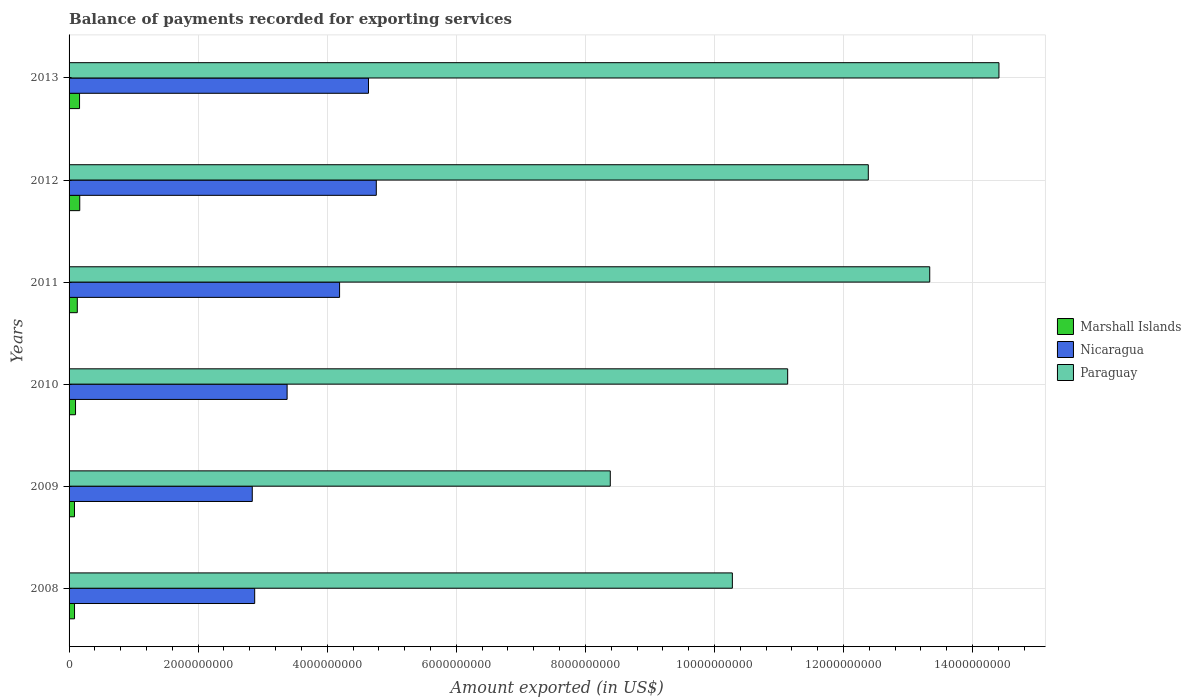How many different coloured bars are there?
Your response must be concise. 3. How many bars are there on the 2nd tick from the top?
Your answer should be very brief. 3. What is the amount exported in Paraguay in 2009?
Offer a very short reply. 8.39e+09. Across all years, what is the maximum amount exported in Marshall Islands?
Keep it short and to the point. 1.65e+08. Across all years, what is the minimum amount exported in Nicaragua?
Keep it short and to the point. 2.84e+09. In which year was the amount exported in Paraguay maximum?
Offer a very short reply. 2013. What is the total amount exported in Paraguay in the graph?
Provide a succinct answer. 6.99e+1. What is the difference between the amount exported in Marshall Islands in 2008 and that in 2011?
Offer a terse response. -4.29e+07. What is the difference between the amount exported in Marshall Islands in 2009 and the amount exported in Paraguay in 2011?
Make the answer very short. -1.33e+1. What is the average amount exported in Marshall Islands per year?
Your answer should be compact. 1.21e+08. In the year 2011, what is the difference between the amount exported in Nicaragua and amount exported in Paraguay?
Offer a terse response. -9.14e+09. What is the ratio of the amount exported in Marshall Islands in 2011 to that in 2013?
Keep it short and to the point. 0.79. What is the difference between the highest and the second highest amount exported in Paraguay?
Ensure brevity in your answer.  1.07e+09. What is the difference between the highest and the lowest amount exported in Nicaragua?
Provide a short and direct response. 1.92e+09. In how many years, is the amount exported in Paraguay greater than the average amount exported in Paraguay taken over all years?
Provide a succinct answer. 3. Is the sum of the amount exported in Nicaragua in 2008 and 2013 greater than the maximum amount exported in Paraguay across all years?
Ensure brevity in your answer.  No. What does the 1st bar from the top in 2009 represents?
Keep it short and to the point. Paraguay. What does the 3rd bar from the bottom in 2013 represents?
Keep it short and to the point. Paraguay. Is it the case that in every year, the sum of the amount exported in Nicaragua and amount exported in Marshall Islands is greater than the amount exported in Paraguay?
Give a very brief answer. No. How many bars are there?
Provide a short and direct response. 18. Are all the bars in the graph horizontal?
Give a very brief answer. Yes. What is the difference between two consecutive major ticks on the X-axis?
Provide a succinct answer. 2.00e+09. Does the graph contain grids?
Ensure brevity in your answer.  Yes. How many legend labels are there?
Keep it short and to the point. 3. What is the title of the graph?
Provide a short and direct response. Balance of payments recorded for exporting services. What is the label or title of the X-axis?
Give a very brief answer. Amount exported (in US$). What is the Amount exported (in US$) of Marshall Islands in 2008?
Offer a terse response. 8.45e+07. What is the Amount exported (in US$) of Nicaragua in 2008?
Your answer should be compact. 2.88e+09. What is the Amount exported (in US$) in Paraguay in 2008?
Give a very brief answer. 1.03e+1. What is the Amount exported (in US$) of Marshall Islands in 2009?
Ensure brevity in your answer.  8.38e+07. What is the Amount exported (in US$) of Nicaragua in 2009?
Your answer should be compact. 2.84e+09. What is the Amount exported (in US$) in Paraguay in 2009?
Your answer should be compact. 8.39e+09. What is the Amount exported (in US$) of Marshall Islands in 2010?
Make the answer very short. 1.00e+08. What is the Amount exported (in US$) in Nicaragua in 2010?
Ensure brevity in your answer.  3.38e+09. What is the Amount exported (in US$) in Paraguay in 2010?
Your response must be concise. 1.11e+1. What is the Amount exported (in US$) in Marshall Islands in 2011?
Give a very brief answer. 1.27e+08. What is the Amount exported (in US$) in Nicaragua in 2011?
Your answer should be very brief. 4.19e+09. What is the Amount exported (in US$) of Paraguay in 2011?
Give a very brief answer. 1.33e+1. What is the Amount exported (in US$) of Marshall Islands in 2012?
Keep it short and to the point. 1.65e+08. What is the Amount exported (in US$) in Nicaragua in 2012?
Your answer should be very brief. 4.76e+09. What is the Amount exported (in US$) of Paraguay in 2012?
Your answer should be compact. 1.24e+1. What is the Amount exported (in US$) of Marshall Islands in 2013?
Your answer should be very brief. 1.62e+08. What is the Amount exported (in US$) in Nicaragua in 2013?
Provide a short and direct response. 4.64e+09. What is the Amount exported (in US$) in Paraguay in 2013?
Offer a very short reply. 1.44e+1. Across all years, what is the maximum Amount exported (in US$) of Marshall Islands?
Provide a short and direct response. 1.65e+08. Across all years, what is the maximum Amount exported (in US$) of Nicaragua?
Offer a terse response. 4.76e+09. Across all years, what is the maximum Amount exported (in US$) in Paraguay?
Give a very brief answer. 1.44e+1. Across all years, what is the minimum Amount exported (in US$) of Marshall Islands?
Your response must be concise. 8.38e+07. Across all years, what is the minimum Amount exported (in US$) in Nicaragua?
Your answer should be compact. 2.84e+09. Across all years, what is the minimum Amount exported (in US$) of Paraguay?
Your answer should be compact. 8.39e+09. What is the total Amount exported (in US$) in Marshall Islands in the graph?
Make the answer very short. 7.24e+08. What is the total Amount exported (in US$) in Nicaragua in the graph?
Your answer should be very brief. 2.27e+1. What is the total Amount exported (in US$) of Paraguay in the graph?
Keep it short and to the point. 6.99e+1. What is the difference between the Amount exported (in US$) in Marshall Islands in 2008 and that in 2009?
Make the answer very short. 7.06e+05. What is the difference between the Amount exported (in US$) in Nicaragua in 2008 and that in 2009?
Your answer should be compact. 3.75e+07. What is the difference between the Amount exported (in US$) of Paraguay in 2008 and that in 2009?
Provide a short and direct response. 1.89e+09. What is the difference between the Amount exported (in US$) of Marshall Islands in 2008 and that in 2010?
Make the answer very short. -1.57e+07. What is the difference between the Amount exported (in US$) in Nicaragua in 2008 and that in 2010?
Provide a succinct answer. -5.02e+08. What is the difference between the Amount exported (in US$) in Paraguay in 2008 and that in 2010?
Offer a very short reply. -8.57e+08. What is the difference between the Amount exported (in US$) of Marshall Islands in 2008 and that in 2011?
Provide a succinct answer. -4.29e+07. What is the difference between the Amount exported (in US$) in Nicaragua in 2008 and that in 2011?
Provide a succinct answer. -1.32e+09. What is the difference between the Amount exported (in US$) of Paraguay in 2008 and that in 2011?
Ensure brevity in your answer.  -3.06e+09. What is the difference between the Amount exported (in US$) of Marshall Islands in 2008 and that in 2012?
Provide a short and direct response. -8.09e+07. What is the difference between the Amount exported (in US$) in Nicaragua in 2008 and that in 2012?
Offer a terse response. -1.88e+09. What is the difference between the Amount exported (in US$) of Paraguay in 2008 and that in 2012?
Make the answer very short. -2.11e+09. What is the difference between the Amount exported (in US$) of Marshall Islands in 2008 and that in 2013?
Provide a succinct answer. -7.77e+07. What is the difference between the Amount exported (in US$) in Nicaragua in 2008 and that in 2013?
Give a very brief answer. -1.76e+09. What is the difference between the Amount exported (in US$) of Paraguay in 2008 and that in 2013?
Ensure brevity in your answer.  -4.13e+09. What is the difference between the Amount exported (in US$) of Marshall Islands in 2009 and that in 2010?
Provide a short and direct response. -1.64e+07. What is the difference between the Amount exported (in US$) in Nicaragua in 2009 and that in 2010?
Provide a succinct answer. -5.40e+08. What is the difference between the Amount exported (in US$) in Paraguay in 2009 and that in 2010?
Offer a very short reply. -2.75e+09. What is the difference between the Amount exported (in US$) of Marshall Islands in 2009 and that in 2011?
Keep it short and to the point. -4.36e+07. What is the difference between the Amount exported (in US$) of Nicaragua in 2009 and that in 2011?
Provide a short and direct response. -1.35e+09. What is the difference between the Amount exported (in US$) of Paraguay in 2009 and that in 2011?
Your answer should be compact. -4.95e+09. What is the difference between the Amount exported (in US$) of Marshall Islands in 2009 and that in 2012?
Offer a terse response. -8.16e+07. What is the difference between the Amount exported (in US$) in Nicaragua in 2009 and that in 2012?
Offer a terse response. -1.92e+09. What is the difference between the Amount exported (in US$) of Paraguay in 2009 and that in 2012?
Offer a very short reply. -4.00e+09. What is the difference between the Amount exported (in US$) of Marshall Islands in 2009 and that in 2013?
Offer a very short reply. -7.84e+07. What is the difference between the Amount exported (in US$) in Nicaragua in 2009 and that in 2013?
Offer a terse response. -1.80e+09. What is the difference between the Amount exported (in US$) in Paraguay in 2009 and that in 2013?
Offer a terse response. -6.02e+09. What is the difference between the Amount exported (in US$) in Marshall Islands in 2010 and that in 2011?
Offer a terse response. -2.73e+07. What is the difference between the Amount exported (in US$) of Nicaragua in 2010 and that in 2011?
Give a very brief answer. -8.13e+08. What is the difference between the Amount exported (in US$) of Paraguay in 2010 and that in 2011?
Offer a very short reply. -2.20e+09. What is the difference between the Amount exported (in US$) in Marshall Islands in 2010 and that in 2012?
Your answer should be compact. -6.52e+07. What is the difference between the Amount exported (in US$) in Nicaragua in 2010 and that in 2012?
Provide a succinct answer. -1.38e+09. What is the difference between the Amount exported (in US$) of Paraguay in 2010 and that in 2012?
Ensure brevity in your answer.  -1.25e+09. What is the difference between the Amount exported (in US$) in Marshall Islands in 2010 and that in 2013?
Your answer should be very brief. -6.21e+07. What is the difference between the Amount exported (in US$) of Nicaragua in 2010 and that in 2013?
Offer a very short reply. -1.26e+09. What is the difference between the Amount exported (in US$) of Paraguay in 2010 and that in 2013?
Offer a terse response. -3.27e+09. What is the difference between the Amount exported (in US$) of Marshall Islands in 2011 and that in 2012?
Offer a very short reply. -3.80e+07. What is the difference between the Amount exported (in US$) in Nicaragua in 2011 and that in 2012?
Your response must be concise. -5.69e+08. What is the difference between the Amount exported (in US$) in Paraguay in 2011 and that in 2012?
Offer a very short reply. 9.52e+08. What is the difference between the Amount exported (in US$) of Marshall Islands in 2011 and that in 2013?
Offer a terse response. -3.48e+07. What is the difference between the Amount exported (in US$) of Nicaragua in 2011 and that in 2013?
Offer a terse response. -4.48e+08. What is the difference between the Amount exported (in US$) of Paraguay in 2011 and that in 2013?
Ensure brevity in your answer.  -1.07e+09. What is the difference between the Amount exported (in US$) in Marshall Islands in 2012 and that in 2013?
Your answer should be very brief. 3.17e+06. What is the difference between the Amount exported (in US$) in Nicaragua in 2012 and that in 2013?
Provide a short and direct response. 1.21e+08. What is the difference between the Amount exported (in US$) of Paraguay in 2012 and that in 2013?
Ensure brevity in your answer.  -2.02e+09. What is the difference between the Amount exported (in US$) in Marshall Islands in 2008 and the Amount exported (in US$) in Nicaragua in 2009?
Give a very brief answer. -2.75e+09. What is the difference between the Amount exported (in US$) of Marshall Islands in 2008 and the Amount exported (in US$) of Paraguay in 2009?
Provide a short and direct response. -8.30e+09. What is the difference between the Amount exported (in US$) in Nicaragua in 2008 and the Amount exported (in US$) in Paraguay in 2009?
Offer a very short reply. -5.51e+09. What is the difference between the Amount exported (in US$) in Marshall Islands in 2008 and the Amount exported (in US$) in Nicaragua in 2010?
Provide a succinct answer. -3.29e+09. What is the difference between the Amount exported (in US$) of Marshall Islands in 2008 and the Amount exported (in US$) of Paraguay in 2010?
Provide a succinct answer. -1.11e+1. What is the difference between the Amount exported (in US$) in Nicaragua in 2008 and the Amount exported (in US$) in Paraguay in 2010?
Ensure brevity in your answer.  -8.26e+09. What is the difference between the Amount exported (in US$) in Marshall Islands in 2008 and the Amount exported (in US$) in Nicaragua in 2011?
Make the answer very short. -4.11e+09. What is the difference between the Amount exported (in US$) in Marshall Islands in 2008 and the Amount exported (in US$) in Paraguay in 2011?
Your response must be concise. -1.33e+1. What is the difference between the Amount exported (in US$) of Nicaragua in 2008 and the Amount exported (in US$) of Paraguay in 2011?
Your response must be concise. -1.05e+1. What is the difference between the Amount exported (in US$) in Marshall Islands in 2008 and the Amount exported (in US$) in Nicaragua in 2012?
Provide a short and direct response. -4.68e+09. What is the difference between the Amount exported (in US$) in Marshall Islands in 2008 and the Amount exported (in US$) in Paraguay in 2012?
Offer a very short reply. -1.23e+1. What is the difference between the Amount exported (in US$) of Nicaragua in 2008 and the Amount exported (in US$) of Paraguay in 2012?
Keep it short and to the point. -9.51e+09. What is the difference between the Amount exported (in US$) of Marshall Islands in 2008 and the Amount exported (in US$) of Nicaragua in 2013?
Keep it short and to the point. -4.55e+09. What is the difference between the Amount exported (in US$) in Marshall Islands in 2008 and the Amount exported (in US$) in Paraguay in 2013?
Your response must be concise. -1.43e+1. What is the difference between the Amount exported (in US$) in Nicaragua in 2008 and the Amount exported (in US$) in Paraguay in 2013?
Your answer should be very brief. -1.15e+1. What is the difference between the Amount exported (in US$) in Marshall Islands in 2009 and the Amount exported (in US$) in Nicaragua in 2010?
Make the answer very short. -3.29e+09. What is the difference between the Amount exported (in US$) in Marshall Islands in 2009 and the Amount exported (in US$) in Paraguay in 2010?
Your answer should be compact. -1.11e+1. What is the difference between the Amount exported (in US$) in Nicaragua in 2009 and the Amount exported (in US$) in Paraguay in 2010?
Provide a short and direct response. -8.30e+09. What is the difference between the Amount exported (in US$) of Marshall Islands in 2009 and the Amount exported (in US$) of Nicaragua in 2011?
Your response must be concise. -4.11e+09. What is the difference between the Amount exported (in US$) in Marshall Islands in 2009 and the Amount exported (in US$) in Paraguay in 2011?
Offer a very short reply. -1.33e+1. What is the difference between the Amount exported (in US$) in Nicaragua in 2009 and the Amount exported (in US$) in Paraguay in 2011?
Make the answer very short. -1.05e+1. What is the difference between the Amount exported (in US$) of Marshall Islands in 2009 and the Amount exported (in US$) of Nicaragua in 2012?
Your response must be concise. -4.68e+09. What is the difference between the Amount exported (in US$) in Marshall Islands in 2009 and the Amount exported (in US$) in Paraguay in 2012?
Provide a succinct answer. -1.23e+1. What is the difference between the Amount exported (in US$) in Nicaragua in 2009 and the Amount exported (in US$) in Paraguay in 2012?
Keep it short and to the point. -9.55e+09. What is the difference between the Amount exported (in US$) in Marshall Islands in 2009 and the Amount exported (in US$) in Nicaragua in 2013?
Offer a very short reply. -4.56e+09. What is the difference between the Amount exported (in US$) of Marshall Islands in 2009 and the Amount exported (in US$) of Paraguay in 2013?
Your answer should be compact. -1.43e+1. What is the difference between the Amount exported (in US$) of Nicaragua in 2009 and the Amount exported (in US$) of Paraguay in 2013?
Your response must be concise. -1.16e+1. What is the difference between the Amount exported (in US$) of Marshall Islands in 2010 and the Amount exported (in US$) of Nicaragua in 2011?
Give a very brief answer. -4.09e+09. What is the difference between the Amount exported (in US$) of Marshall Islands in 2010 and the Amount exported (in US$) of Paraguay in 2011?
Keep it short and to the point. -1.32e+1. What is the difference between the Amount exported (in US$) in Nicaragua in 2010 and the Amount exported (in US$) in Paraguay in 2011?
Make the answer very short. -9.96e+09. What is the difference between the Amount exported (in US$) of Marshall Islands in 2010 and the Amount exported (in US$) of Nicaragua in 2012?
Keep it short and to the point. -4.66e+09. What is the difference between the Amount exported (in US$) in Marshall Islands in 2010 and the Amount exported (in US$) in Paraguay in 2012?
Offer a very short reply. -1.23e+1. What is the difference between the Amount exported (in US$) of Nicaragua in 2010 and the Amount exported (in US$) of Paraguay in 2012?
Keep it short and to the point. -9.01e+09. What is the difference between the Amount exported (in US$) in Marshall Islands in 2010 and the Amount exported (in US$) in Nicaragua in 2013?
Your response must be concise. -4.54e+09. What is the difference between the Amount exported (in US$) of Marshall Islands in 2010 and the Amount exported (in US$) of Paraguay in 2013?
Offer a very short reply. -1.43e+1. What is the difference between the Amount exported (in US$) in Nicaragua in 2010 and the Amount exported (in US$) in Paraguay in 2013?
Make the answer very short. -1.10e+1. What is the difference between the Amount exported (in US$) of Marshall Islands in 2011 and the Amount exported (in US$) of Nicaragua in 2012?
Your answer should be compact. -4.63e+09. What is the difference between the Amount exported (in US$) of Marshall Islands in 2011 and the Amount exported (in US$) of Paraguay in 2012?
Ensure brevity in your answer.  -1.23e+1. What is the difference between the Amount exported (in US$) in Nicaragua in 2011 and the Amount exported (in US$) in Paraguay in 2012?
Offer a very short reply. -8.19e+09. What is the difference between the Amount exported (in US$) of Marshall Islands in 2011 and the Amount exported (in US$) of Nicaragua in 2013?
Make the answer very short. -4.51e+09. What is the difference between the Amount exported (in US$) of Marshall Islands in 2011 and the Amount exported (in US$) of Paraguay in 2013?
Provide a short and direct response. -1.43e+1. What is the difference between the Amount exported (in US$) of Nicaragua in 2011 and the Amount exported (in US$) of Paraguay in 2013?
Provide a succinct answer. -1.02e+1. What is the difference between the Amount exported (in US$) of Marshall Islands in 2012 and the Amount exported (in US$) of Nicaragua in 2013?
Give a very brief answer. -4.47e+09. What is the difference between the Amount exported (in US$) in Marshall Islands in 2012 and the Amount exported (in US$) in Paraguay in 2013?
Give a very brief answer. -1.42e+1. What is the difference between the Amount exported (in US$) in Nicaragua in 2012 and the Amount exported (in US$) in Paraguay in 2013?
Give a very brief answer. -9.65e+09. What is the average Amount exported (in US$) in Marshall Islands per year?
Offer a very short reply. 1.21e+08. What is the average Amount exported (in US$) in Nicaragua per year?
Give a very brief answer. 3.78e+09. What is the average Amount exported (in US$) in Paraguay per year?
Your answer should be very brief. 1.17e+1. In the year 2008, what is the difference between the Amount exported (in US$) of Marshall Islands and Amount exported (in US$) of Nicaragua?
Give a very brief answer. -2.79e+09. In the year 2008, what is the difference between the Amount exported (in US$) in Marshall Islands and Amount exported (in US$) in Paraguay?
Your response must be concise. -1.02e+1. In the year 2008, what is the difference between the Amount exported (in US$) of Nicaragua and Amount exported (in US$) of Paraguay?
Provide a short and direct response. -7.40e+09. In the year 2009, what is the difference between the Amount exported (in US$) in Marshall Islands and Amount exported (in US$) in Nicaragua?
Ensure brevity in your answer.  -2.75e+09. In the year 2009, what is the difference between the Amount exported (in US$) of Marshall Islands and Amount exported (in US$) of Paraguay?
Your response must be concise. -8.30e+09. In the year 2009, what is the difference between the Amount exported (in US$) of Nicaragua and Amount exported (in US$) of Paraguay?
Provide a succinct answer. -5.55e+09. In the year 2010, what is the difference between the Amount exported (in US$) in Marshall Islands and Amount exported (in US$) in Nicaragua?
Provide a short and direct response. -3.28e+09. In the year 2010, what is the difference between the Amount exported (in US$) of Marshall Islands and Amount exported (in US$) of Paraguay?
Offer a very short reply. -1.10e+1. In the year 2010, what is the difference between the Amount exported (in US$) in Nicaragua and Amount exported (in US$) in Paraguay?
Give a very brief answer. -7.76e+09. In the year 2011, what is the difference between the Amount exported (in US$) of Marshall Islands and Amount exported (in US$) of Nicaragua?
Give a very brief answer. -4.06e+09. In the year 2011, what is the difference between the Amount exported (in US$) in Marshall Islands and Amount exported (in US$) in Paraguay?
Provide a succinct answer. -1.32e+1. In the year 2011, what is the difference between the Amount exported (in US$) of Nicaragua and Amount exported (in US$) of Paraguay?
Give a very brief answer. -9.14e+09. In the year 2012, what is the difference between the Amount exported (in US$) in Marshall Islands and Amount exported (in US$) in Nicaragua?
Offer a terse response. -4.59e+09. In the year 2012, what is the difference between the Amount exported (in US$) in Marshall Islands and Amount exported (in US$) in Paraguay?
Give a very brief answer. -1.22e+1. In the year 2012, what is the difference between the Amount exported (in US$) of Nicaragua and Amount exported (in US$) of Paraguay?
Your response must be concise. -7.62e+09. In the year 2013, what is the difference between the Amount exported (in US$) in Marshall Islands and Amount exported (in US$) in Nicaragua?
Provide a short and direct response. -4.48e+09. In the year 2013, what is the difference between the Amount exported (in US$) in Marshall Islands and Amount exported (in US$) in Paraguay?
Keep it short and to the point. -1.42e+1. In the year 2013, what is the difference between the Amount exported (in US$) in Nicaragua and Amount exported (in US$) in Paraguay?
Make the answer very short. -9.77e+09. What is the ratio of the Amount exported (in US$) of Marshall Islands in 2008 to that in 2009?
Ensure brevity in your answer.  1.01. What is the ratio of the Amount exported (in US$) in Nicaragua in 2008 to that in 2009?
Your answer should be compact. 1.01. What is the ratio of the Amount exported (in US$) in Paraguay in 2008 to that in 2009?
Your answer should be compact. 1.23. What is the ratio of the Amount exported (in US$) of Marshall Islands in 2008 to that in 2010?
Make the answer very short. 0.84. What is the ratio of the Amount exported (in US$) in Nicaragua in 2008 to that in 2010?
Make the answer very short. 0.85. What is the ratio of the Amount exported (in US$) of Paraguay in 2008 to that in 2010?
Provide a succinct answer. 0.92. What is the ratio of the Amount exported (in US$) of Marshall Islands in 2008 to that in 2011?
Your answer should be very brief. 0.66. What is the ratio of the Amount exported (in US$) in Nicaragua in 2008 to that in 2011?
Make the answer very short. 0.69. What is the ratio of the Amount exported (in US$) of Paraguay in 2008 to that in 2011?
Offer a terse response. 0.77. What is the ratio of the Amount exported (in US$) in Marshall Islands in 2008 to that in 2012?
Ensure brevity in your answer.  0.51. What is the ratio of the Amount exported (in US$) of Nicaragua in 2008 to that in 2012?
Keep it short and to the point. 0.6. What is the ratio of the Amount exported (in US$) of Paraguay in 2008 to that in 2012?
Give a very brief answer. 0.83. What is the ratio of the Amount exported (in US$) of Marshall Islands in 2008 to that in 2013?
Make the answer very short. 0.52. What is the ratio of the Amount exported (in US$) of Nicaragua in 2008 to that in 2013?
Your answer should be very brief. 0.62. What is the ratio of the Amount exported (in US$) of Paraguay in 2008 to that in 2013?
Provide a succinct answer. 0.71. What is the ratio of the Amount exported (in US$) of Marshall Islands in 2009 to that in 2010?
Keep it short and to the point. 0.84. What is the ratio of the Amount exported (in US$) in Nicaragua in 2009 to that in 2010?
Provide a succinct answer. 0.84. What is the ratio of the Amount exported (in US$) of Paraguay in 2009 to that in 2010?
Provide a short and direct response. 0.75. What is the ratio of the Amount exported (in US$) in Marshall Islands in 2009 to that in 2011?
Offer a very short reply. 0.66. What is the ratio of the Amount exported (in US$) in Nicaragua in 2009 to that in 2011?
Make the answer very short. 0.68. What is the ratio of the Amount exported (in US$) in Paraguay in 2009 to that in 2011?
Make the answer very short. 0.63. What is the ratio of the Amount exported (in US$) of Marshall Islands in 2009 to that in 2012?
Your answer should be compact. 0.51. What is the ratio of the Amount exported (in US$) in Nicaragua in 2009 to that in 2012?
Offer a very short reply. 0.6. What is the ratio of the Amount exported (in US$) in Paraguay in 2009 to that in 2012?
Your answer should be very brief. 0.68. What is the ratio of the Amount exported (in US$) in Marshall Islands in 2009 to that in 2013?
Make the answer very short. 0.52. What is the ratio of the Amount exported (in US$) of Nicaragua in 2009 to that in 2013?
Give a very brief answer. 0.61. What is the ratio of the Amount exported (in US$) in Paraguay in 2009 to that in 2013?
Give a very brief answer. 0.58. What is the ratio of the Amount exported (in US$) in Marshall Islands in 2010 to that in 2011?
Provide a succinct answer. 0.79. What is the ratio of the Amount exported (in US$) in Nicaragua in 2010 to that in 2011?
Your answer should be very brief. 0.81. What is the ratio of the Amount exported (in US$) of Paraguay in 2010 to that in 2011?
Your response must be concise. 0.83. What is the ratio of the Amount exported (in US$) of Marshall Islands in 2010 to that in 2012?
Ensure brevity in your answer.  0.61. What is the ratio of the Amount exported (in US$) of Nicaragua in 2010 to that in 2012?
Give a very brief answer. 0.71. What is the ratio of the Amount exported (in US$) of Paraguay in 2010 to that in 2012?
Offer a very short reply. 0.9. What is the ratio of the Amount exported (in US$) of Marshall Islands in 2010 to that in 2013?
Keep it short and to the point. 0.62. What is the ratio of the Amount exported (in US$) in Nicaragua in 2010 to that in 2013?
Offer a very short reply. 0.73. What is the ratio of the Amount exported (in US$) of Paraguay in 2010 to that in 2013?
Give a very brief answer. 0.77. What is the ratio of the Amount exported (in US$) of Marshall Islands in 2011 to that in 2012?
Ensure brevity in your answer.  0.77. What is the ratio of the Amount exported (in US$) of Nicaragua in 2011 to that in 2012?
Keep it short and to the point. 0.88. What is the ratio of the Amount exported (in US$) in Paraguay in 2011 to that in 2012?
Offer a very short reply. 1.08. What is the ratio of the Amount exported (in US$) of Marshall Islands in 2011 to that in 2013?
Give a very brief answer. 0.79. What is the ratio of the Amount exported (in US$) of Nicaragua in 2011 to that in 2013?
Your response must be concise. 0.9. What is the ratio of the Amount exported (in US$) in Paraguay in 2011 to that in 2013?
Keep it short and to the point. 0.93. What is the ratio of the Amount exported (in US$) in Marshall Islands in 2012 to that in 2013?
Offer a terse response. 1.02. What is the ratio of the Amount exported (in US$) of Nicaragua in 2012 to that in 2013?
Offer a terse response. 1.03. What is the ratio of the Amount exported (in US$) in Paraguay in 2012 to that in 2013?
Keep it short and to the point. 0.86. What is the difference between the highest and the second highest Amount exported (in US$) of Marshall Islands?
Offer a very short reply. 3.17e+06. What is the difference between the highest and the second highest Amount exported (in US$) in Nicaragua?
Offer a terse response. 1.21e+08. What is the difference between the highest and the second highest Amount exported (in US$) in Paraguay?
Offer a very short reply. 1.07e+09. What is the difference between the highest and the lowest Amount exported (in US$) of Marshall Islands?
Offer a very short reply. 8.16e+07. What is the difference between the highest and the lowest Amount exported (in US$) of Nicaragua?
Ensure brevity in your answer.  1.92e+09. What is the difference between the highest and the lowest Amount exported (in US$) in Paraguay?
Keep it short and to the point. 6.02e+09. 